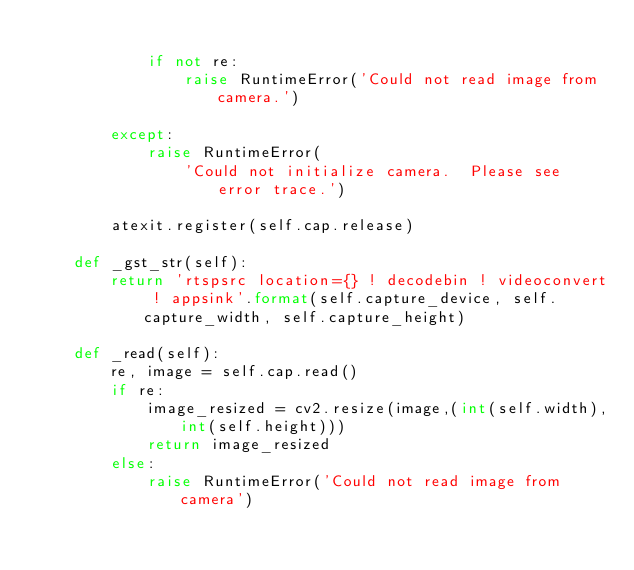Convert code to text. <code><loc_0><loc_0><loc_500><loc_500><_Python_>            
            if not re:
                raise RuntimeError('Could not read image from camera.')
            
        except:
            raise RuntimeError(
                'Could not initialize camera.  Please see error trace.')

        atexit.register(self.cap.release)
                
    def _gst_str(self):
        return 'rtspsrc location={} ! decodebin ! videoconvert ! appsink'.format(self.capture_device, self.capture_width, self.capture_height)
          
    def _read(self):
        re, image = self.cap.read()
        if re:
            image_resized = cv2.resize(image,(int(self.width),int(self.height)))
            return image_resized
        else:
            raise RuntimeError('Could not read image from camera')
</code> 